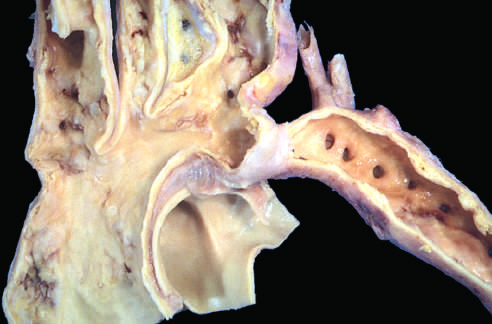s schematic diagram of intimal thickening a segmental narrowing of the aorta?
Answer the question using a single word or phrase. No 